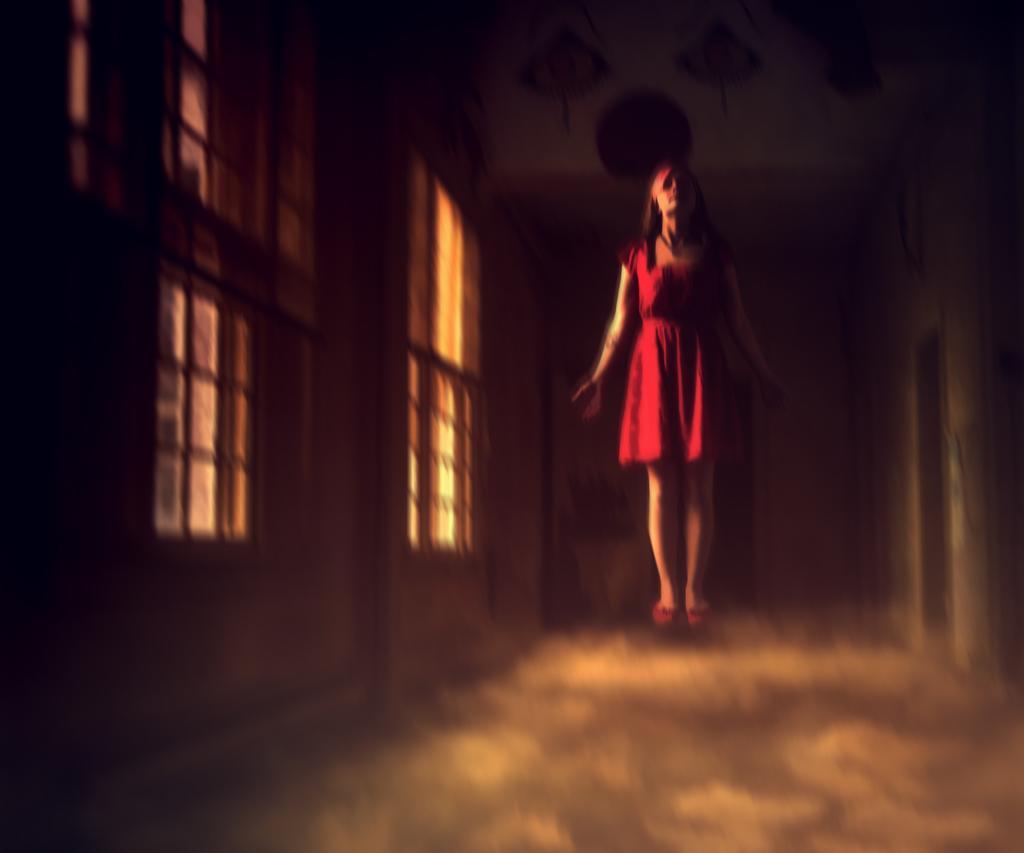How would you summarize this image in a sentence or two? In this picture we can see a woman, she wore a red color dress, and we can see dark background. 